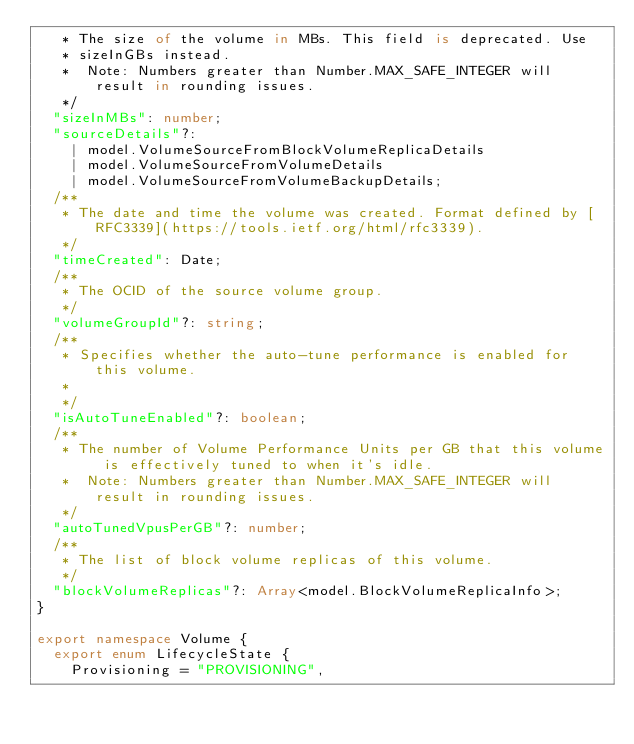Convert code to text. <code><loc_0><loc_0><loc_500><loc_500><_TypeScript_>   * The size of the volume in MBs. This field is deprecated. Use
   * sizeInGBs instead.
   *  Note: Numbers greater than Number.MAX_SAFE_INTEGER will result in rounding issues.
   */
  "sizeInMBs": number;
  "sourceDetails"?:
    | model.VolumeSourceFromBlockVolumeReplicaDetails
    | model.VolumeSourceFromVolumeDetails
    | model.VolumeSourceFromVolumeBackupDetails;
  /**
   * The date and time the volume was created. Format defined by [RFC3339](https://tools.ietf.org/html/rfc3339).
   */
  "timeCreated": Date;
  /**
   * The OCID of the source volume group.
   */
  "volumeGroupId"?: string;
  /**
   * Specifies whether the auto-tune performance is enabled for this volume.
   *
   */
  "isAutoTuneEnabled"?: boolean;
  /**
   * The number of Volume Performance Units per GB that this volume is effectively tuned to when it's idle.
   *  Note: Numbers greater than Number.MAX_SAFE_INTEGER will result in rounding issues.
   */
  "autoTunedVpusPerGB"?: number;
  /**
   * The list of block volume replicas of this volume.
   */
  "blockVolumeReplicas"?: Array<model.BlockVolumeReplicaInfo>;
}

export namespace Volume {
  export enum LifecycleState {
    Provisioning = "PROVISIONING",</code> 